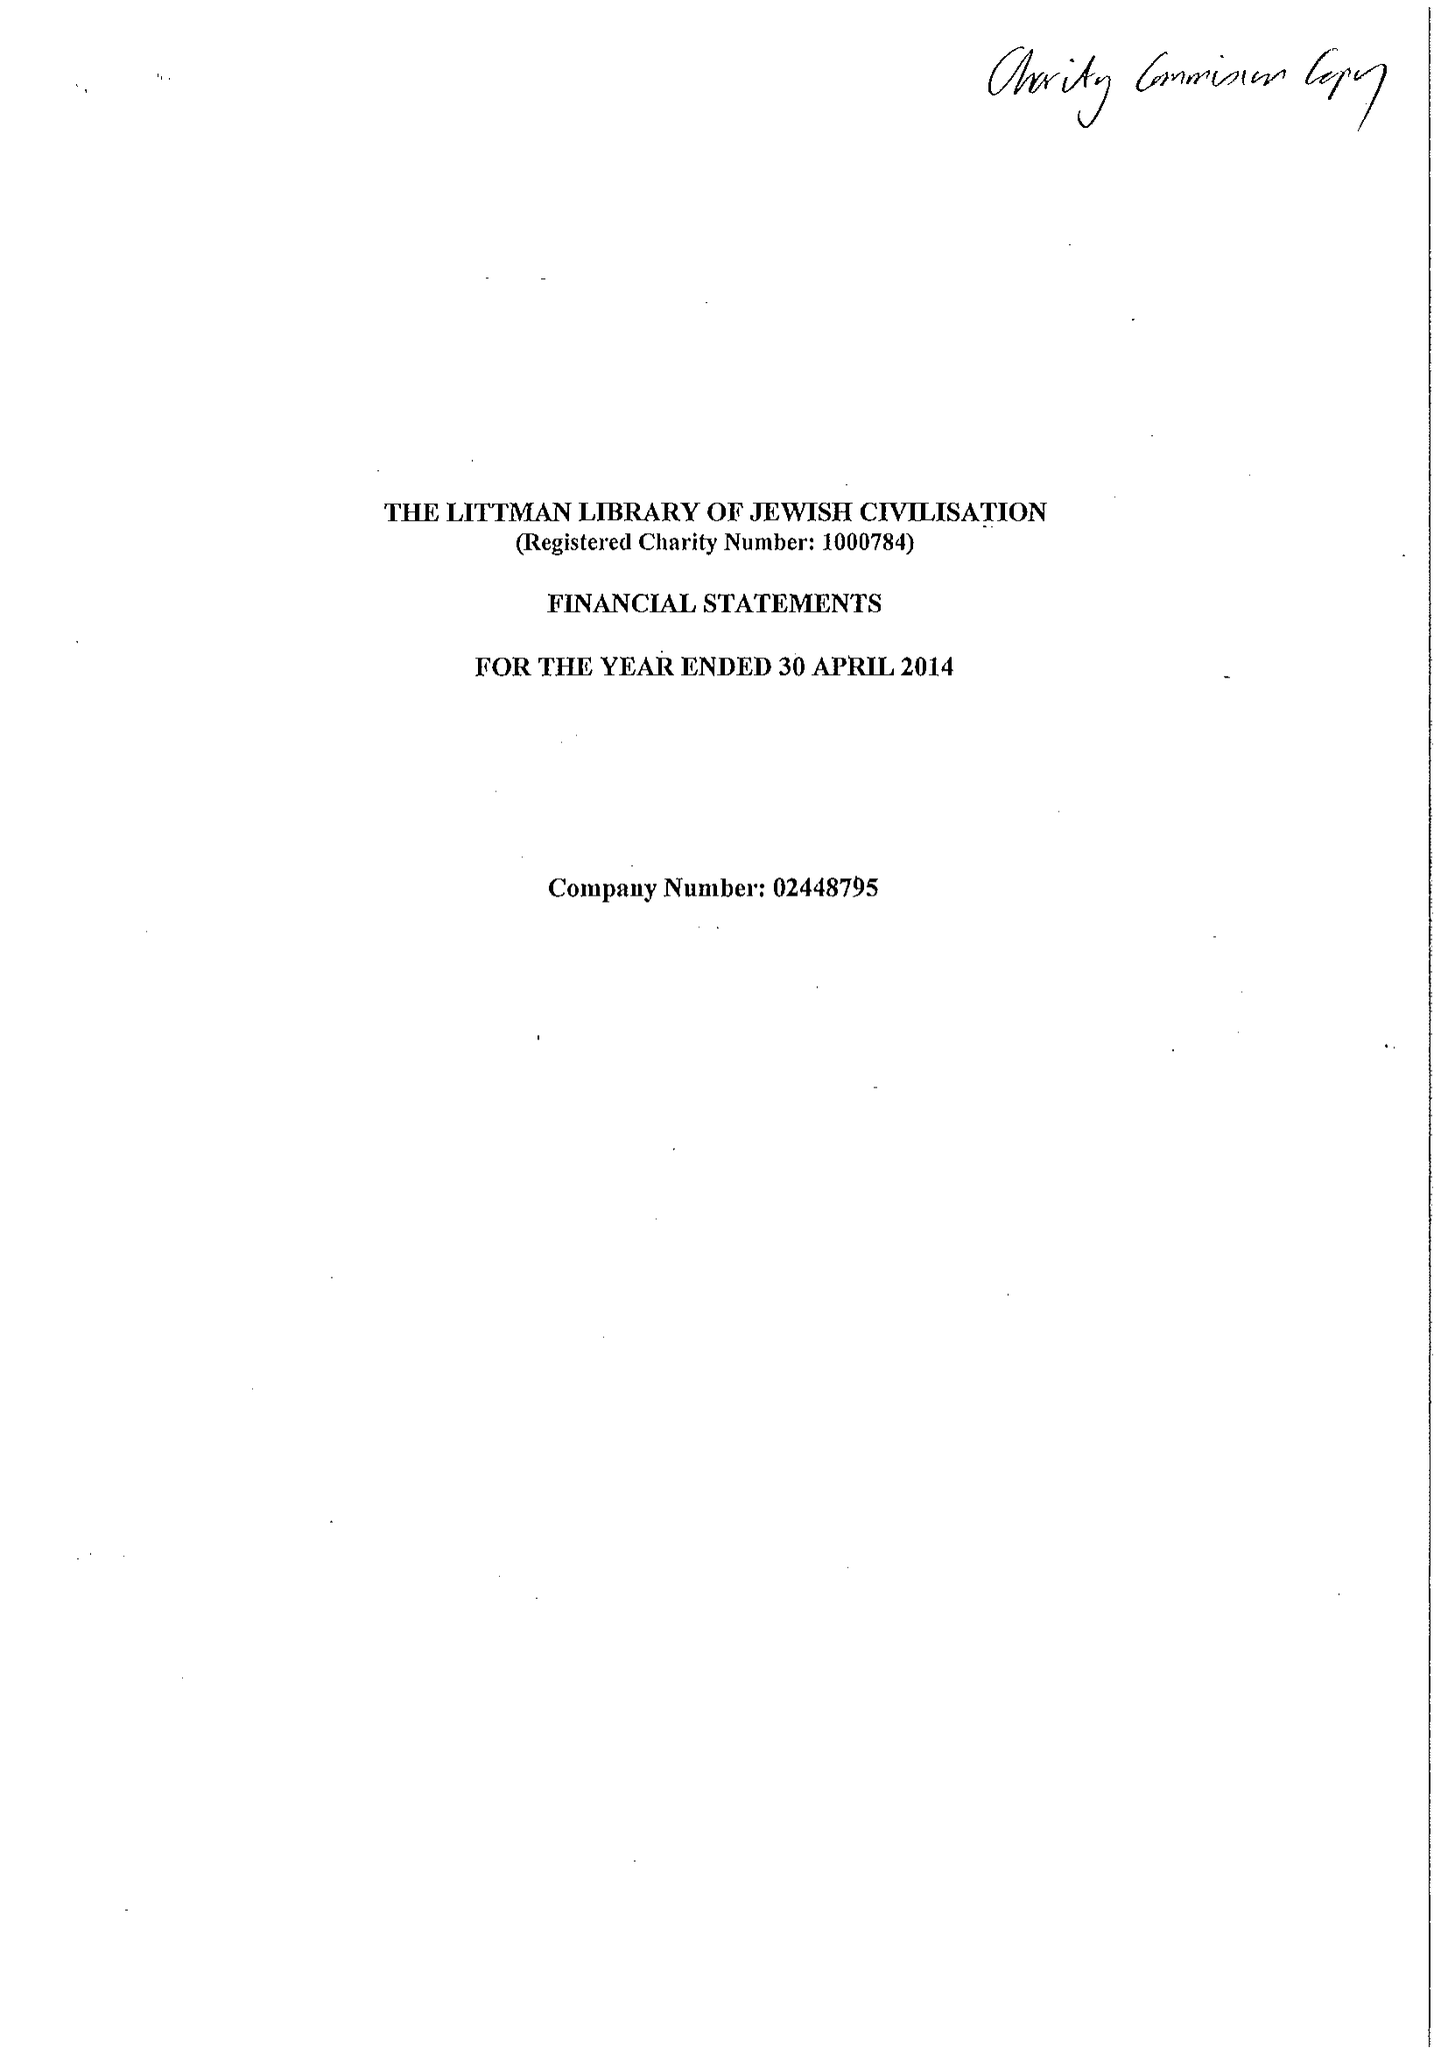What is the value for the charity_name?
Answer the question using a single word or phrase. The Littman Library Of Jewish Civilisation 